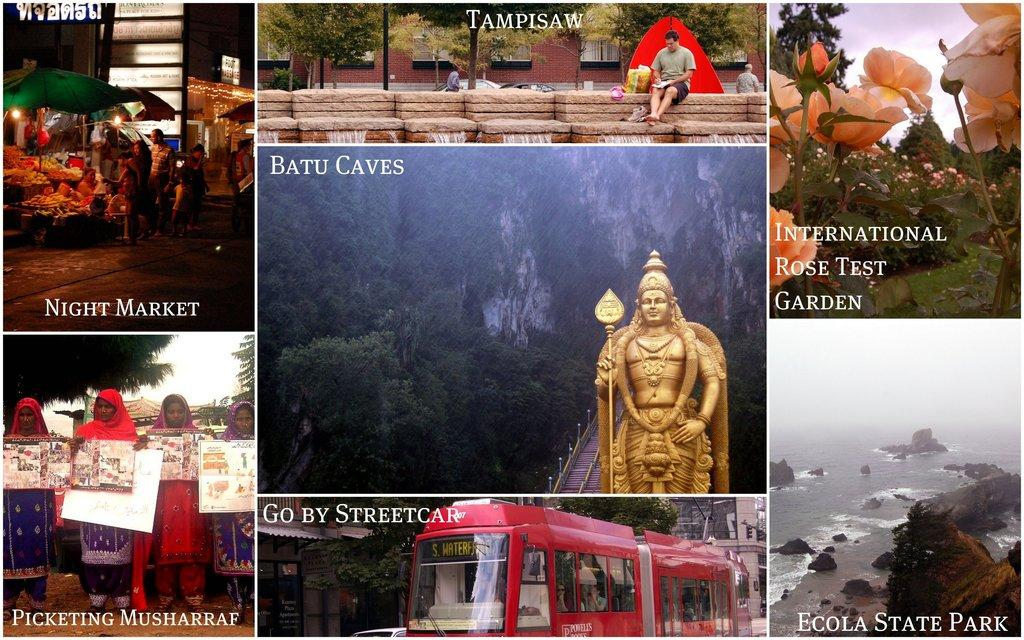<image>
Write a terse but informative summary of the picture. A picture of the Batu Caves and many other landmarks. 